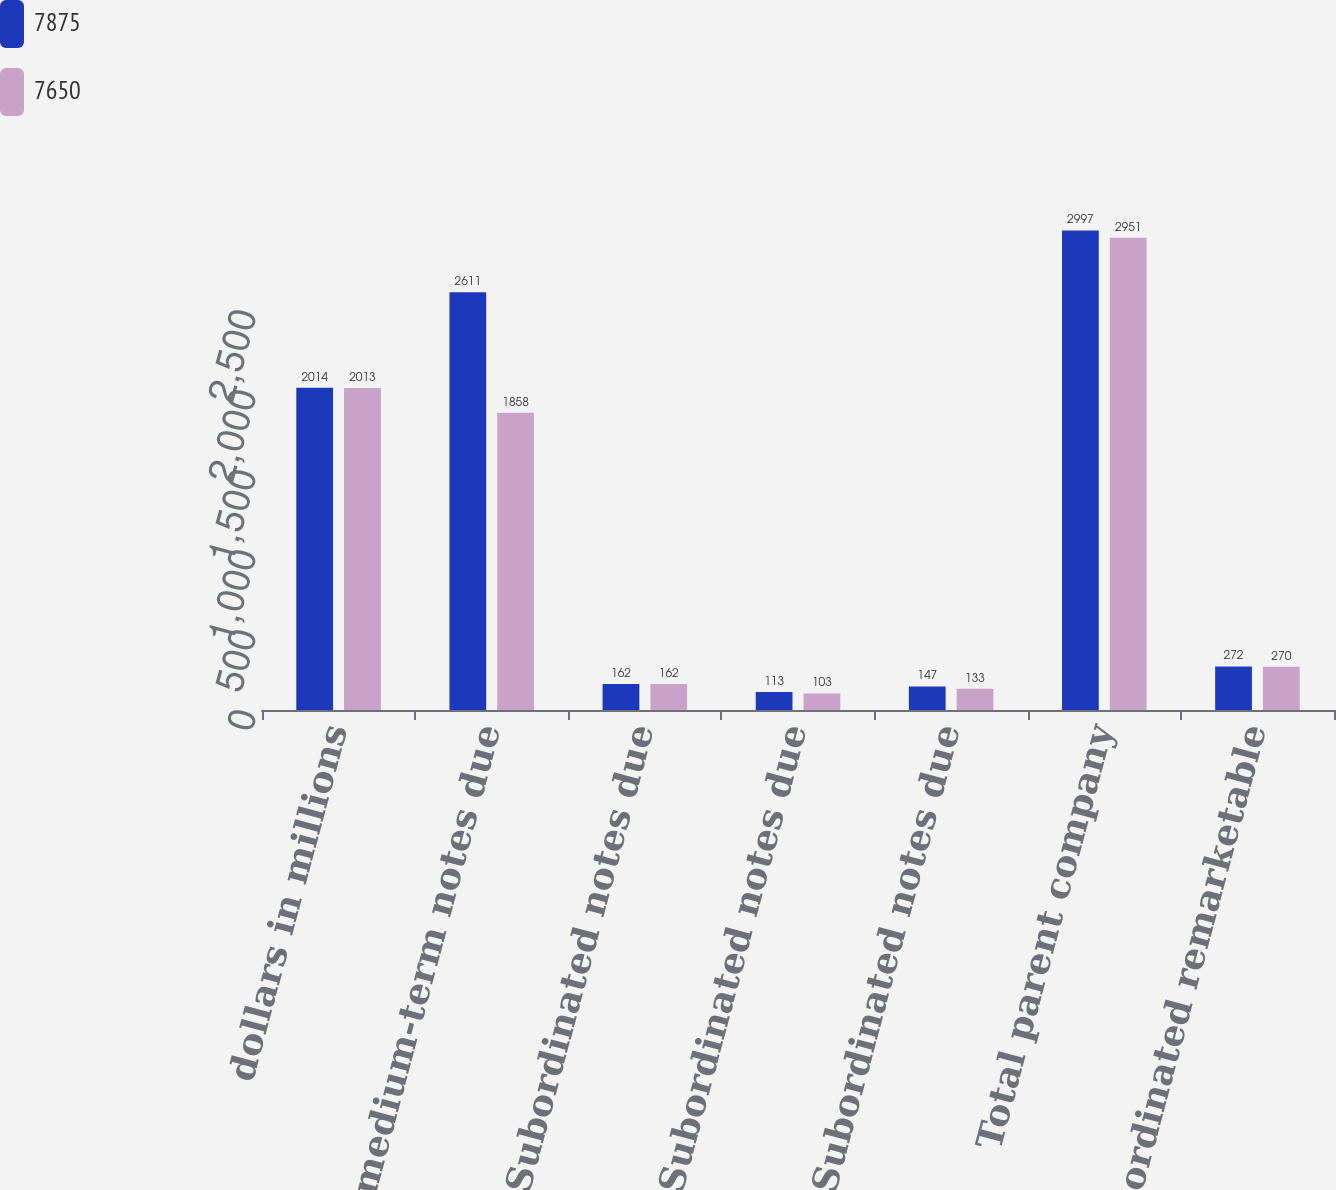<chart> <loc_0><loc_0><loc_500><loc_500><stacked_bar_chart><ecel><fcel>dollars in millions<fcel>Senior medium-term notes due<fcel>0975 Subordinated notes due<fcel>6875 Subordinated notes due<fcel>7750 Subordinated notes due<fcel>Total parent company<fcel>7413 Subordinated remarketable<nl><fcel>7875<fcel>2014<fcel>2611<fcel>162<fcel>113<fcel>147<fcel>2997<fcel>272<nl><fcel>7650<fcel>2013<fcel>1858<fcel>162<fcel>103<fcel>133<fcel>2951<fcel>270<nl></chart> 